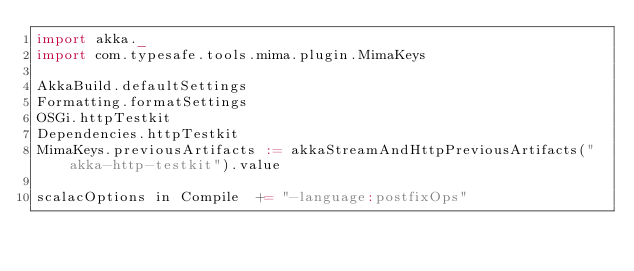<code> <loc_0><loc_0><loc_500><loc_500><_Scala_>import akka._
import com.typesafe.tools.mima.plugin.MimaKeys

AkkaBuild.defaultSettings
Formatting.formatSettings
OSGi.httpTestkit
Dependencies.httpTestkit
MimaKeys.previousArtifacts := akkaStreamAndHttpPreviousArtifacts("akka-http-testkit").value

scalacOptions in Compile  += "-language:postfixOps"
</code> 